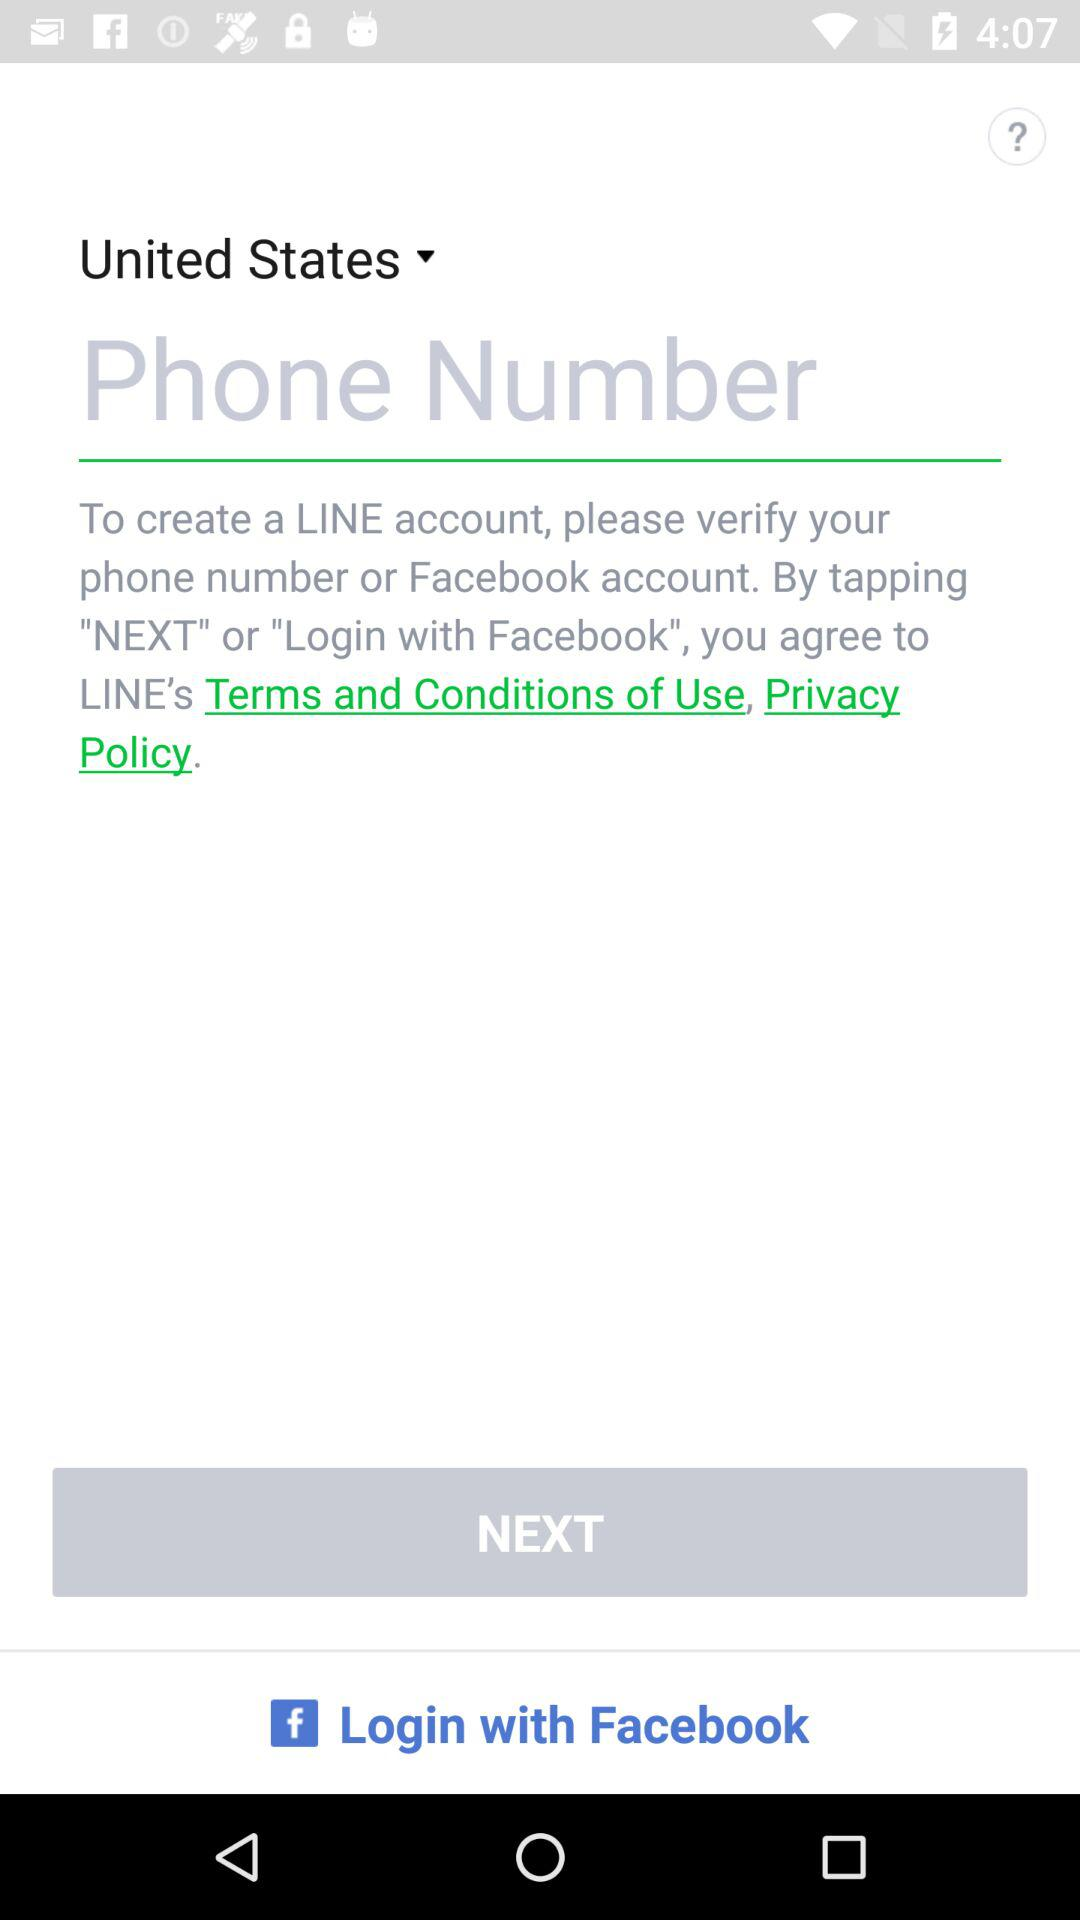What account can I login to? You can login with "Facebook". 